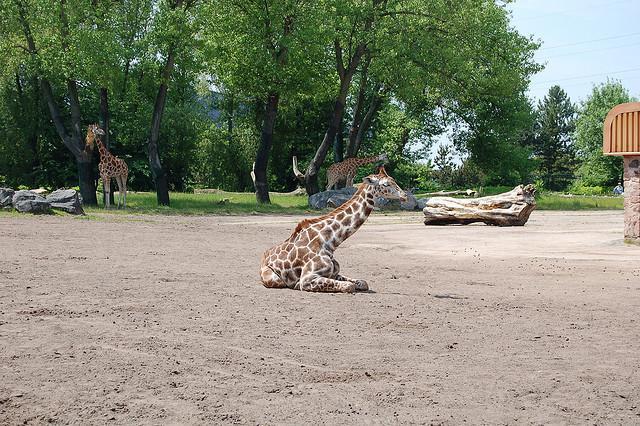What us the giraffe in the foreground sitting on?
Select the accurate answer and provide explanation: 'Answer: answer
Rationale: rationale.'
Options: Sand, water, box, snow. Answer: sand.
Rationale: An animal with a long neck is sitting in a lightly colored, fine grain soil with no trees or bushes growing out of it. 